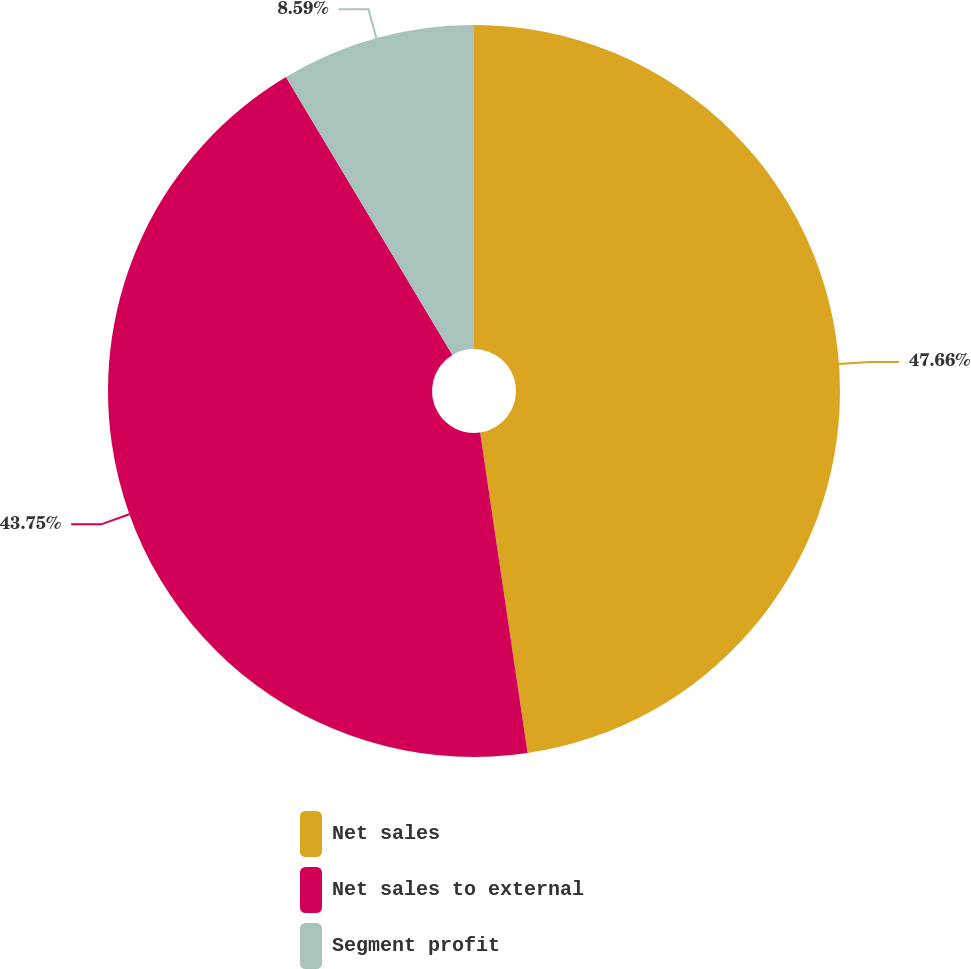Convert chart to OTSL. <chart><loc_0><loc_0><loc_500><loc_500><pie_chart><fcel>Net sales<fcel>Net sales to external<fcel>Segment profit<nl><fcel>47.66%<fcel>43.75%<fcel>8.59%<nl></chart> 